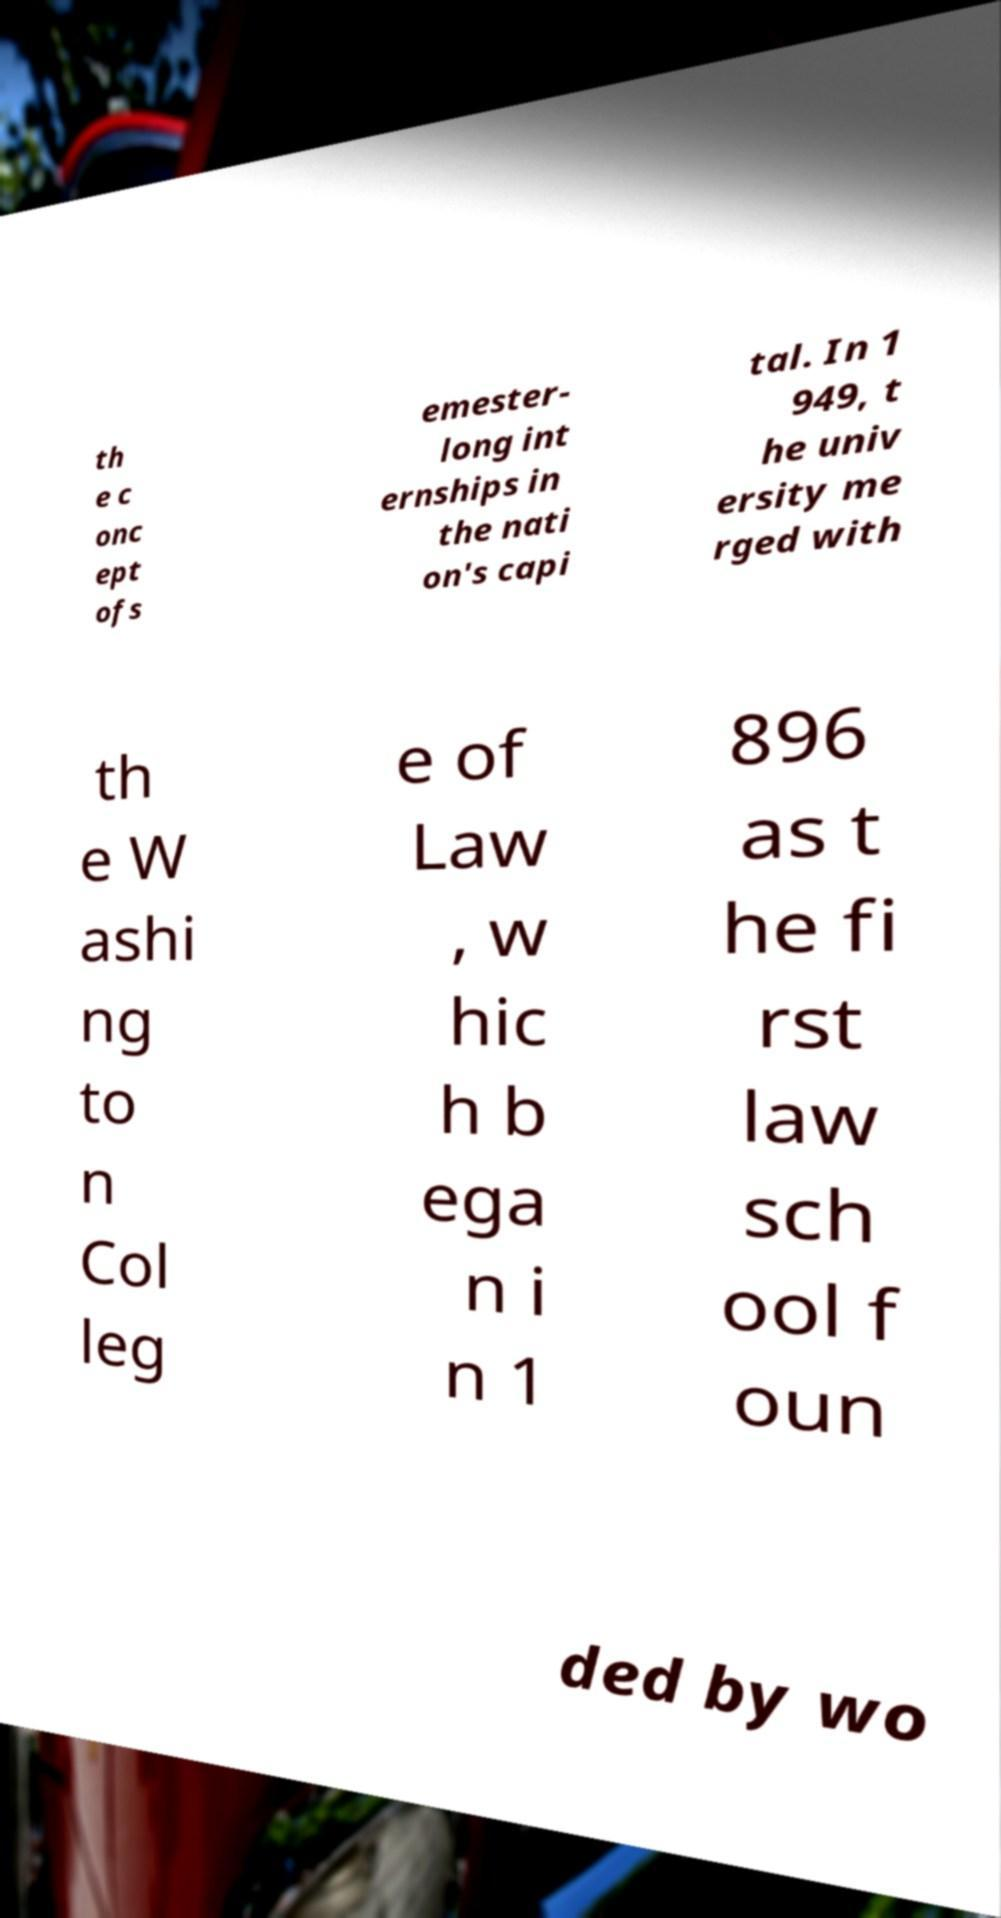Could you extract and type out the text from this image? th e c onc ept ofs emester- long int ernships in the nati on's capi tal. In 1 949, t he univ ersity me rged with th e W ashi ng to n Col leg e of Law , w hic h b ega n i n 1 896 as t he fi rst law sch ool f oun ded by wo 